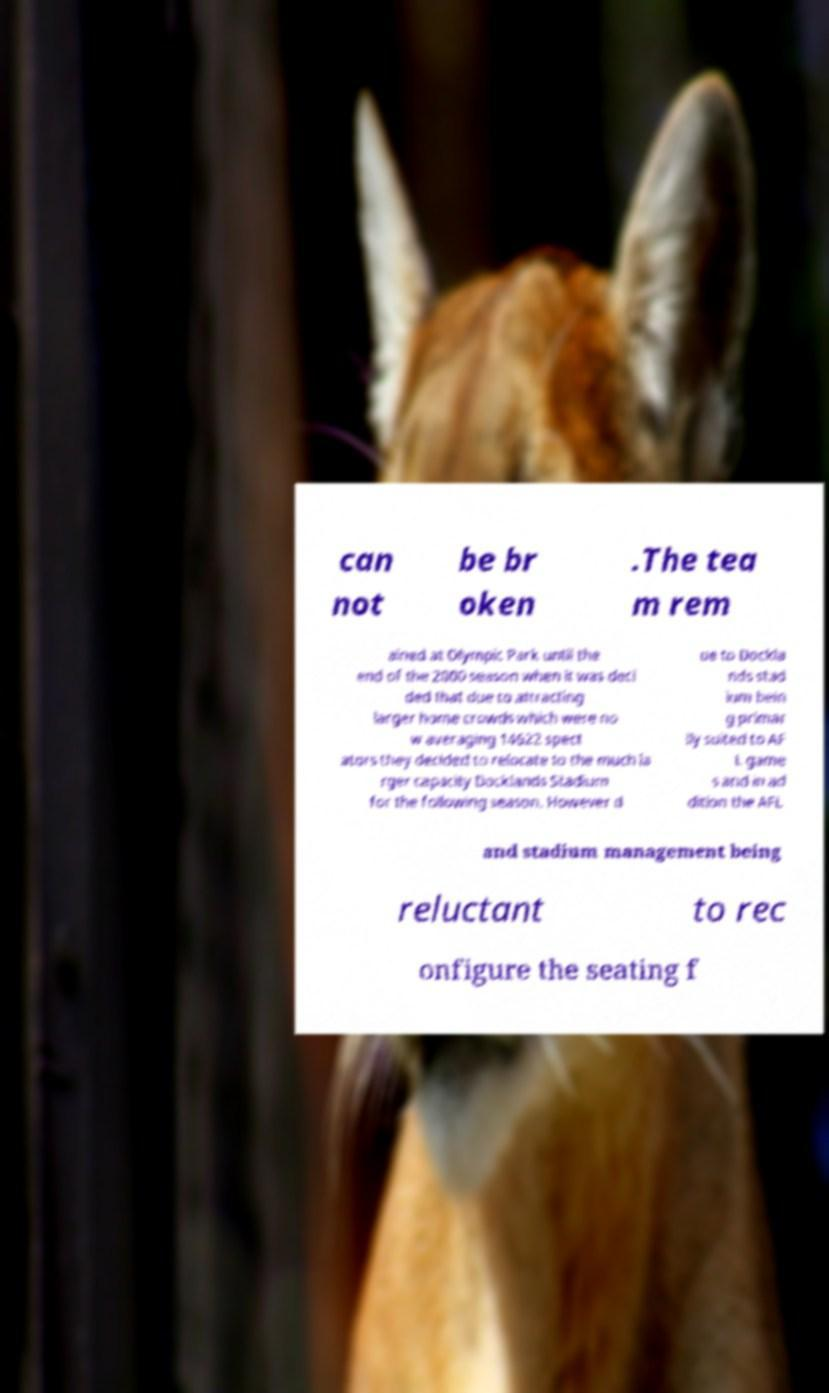For documentation purposes, I need the text within this image transcribed. Could you provide that? can not be br oken .The tea m rem ained at Olympic Park until the end of the 2000 season when it was deci ded that due to attracting larger home crowds which were no w averaging 14622 spect ators they decided to relocate to the much la rger capacity Docklands Stadium for the following season. However d ue to Dockla nds stad ium bein g primar ily suited to AF L game s and in ad dition the AFL and stadium management being reluctant to rec onfigure the seating f 